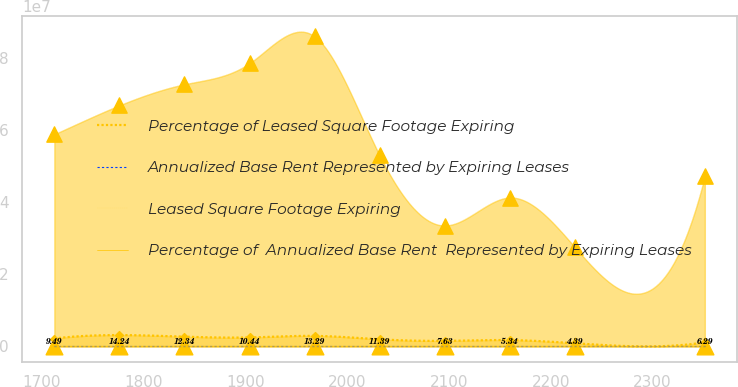<chart> <loc_0><loc_0><loc_500><loc_500><line_chart><ecel><fcel>Percentage of Leased Square Footage Expiring<fcel>Annualized Base Rent Represented by Expiring Leases<fcel>Leased Square Footage Expiring<fcel>Percentage of  Annualized Base Rent  Represented by Expiring Leases<nl><fcel>1712.42<fcel>2.21268e+06<fcel>9.49<fcel>5.8902e+07<fcel>10.77<nl><fcel>1776.31<fcel>3.15993e+06<fcel>14.24<fcel>6.69299e+07<fcel>11.68<nl><fcel>1840.2<fcel>2.72192e+06<fcel>12.34<fcel>7.27793e+07<fcel>12.59<nl><fcel>1904.09<fcel>2.50292e+06<fcel>10.44<fcel>7.86288e+07<fcel>13.5<nl><fcel>1967.98<fcel>2.94093e+06<fcel>13.29<fcel>8.60883e+07<fcel>14.41<nl><fcel>2031.87<fcel>1.99368e+06<fcel>11.39<fcel>5.30526e+07<fcel>8.95<nl><fcel>2095.76<fcel>1.55567e+06<fcel>7.63<fcel>3.35757e+07<fcel>9.86<nl><fcel>2159.65<fcel>1.77468e+06<fcel>5.34<fcel>4.13537e+07<fcel>6.64<nl><fcel>2223.54<fcel>895684<fcel>4.39<fcel>2.75938e+07<fcel>4.41<nl><fcel>2351.28<fcel>1.13603e+06<fcel>6.29<fcel>4.72031e+07<fcel>8.04<nl></chart> 